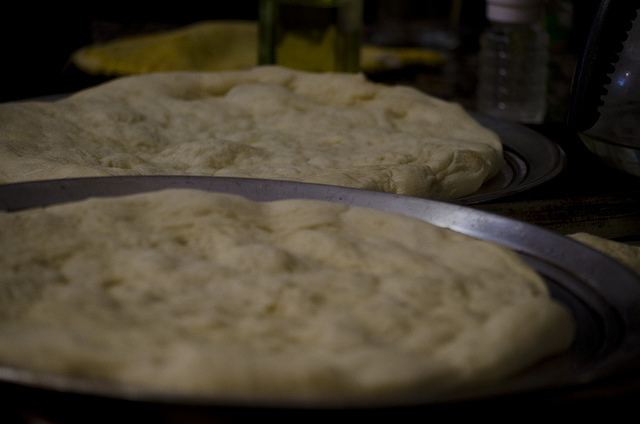<image>What toppings are on the pizza dough? There are no toppings on the pizza dough. What toppings are on the pizza dough? There are no toppings on the pizza dough. 